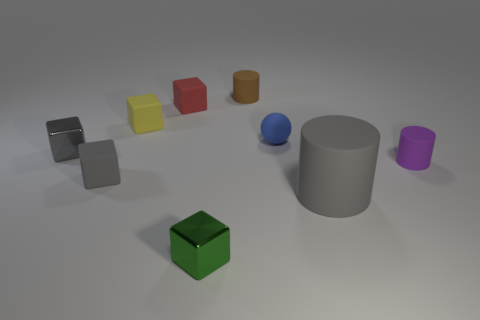Subtract all small cylinders. How many cylinders are left? 1 Subtract all brown cylinders. How many cylinders are left? 2 Subtract all balls. How many objects are left? 8 Subtract 4 blocks. How many blocks are left? 1 Subtract all brown balls. How many yellow cylinders are left? 0 Subtract all yellow matte objects. Subtract all tiny objects. How many objects are left? 0 Add 2 small green blocks. How many small green blocks are left? 3 Add 6 large yellow blocks. How many large yellow blocks exist? 6 Subtract 1 gray cylinders. How many objects are left? 8 Subtract all blue blocks. Subtract all yellow cylinders. How many blocks are left? 5 